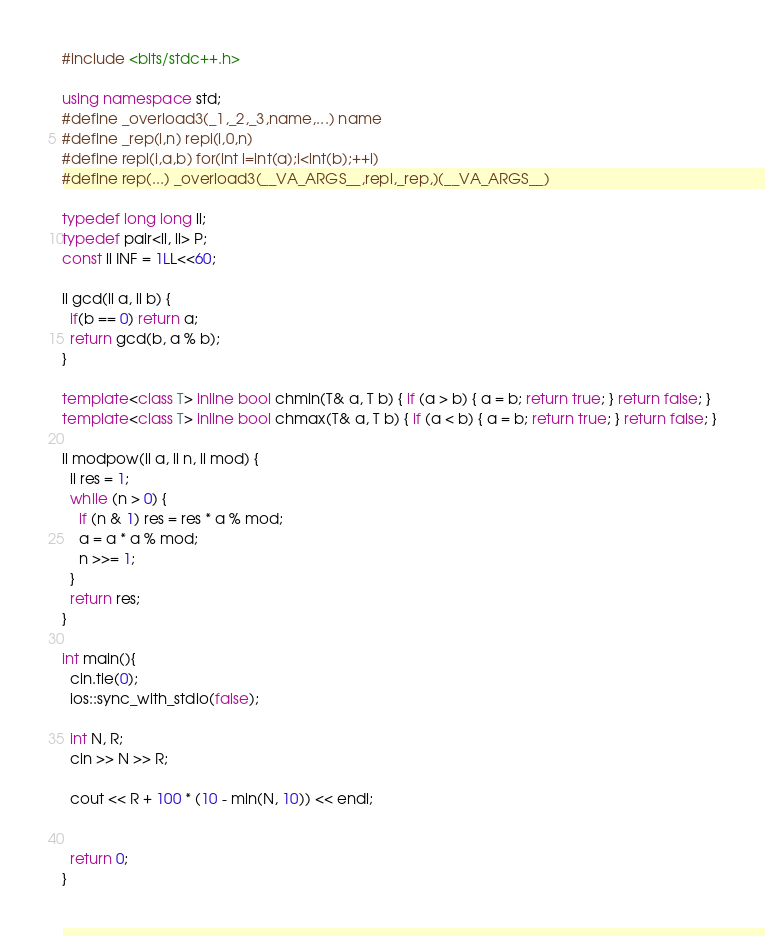Convert code to text. <code><loc_0><loc_0><loc_500><loc_500><_C++_>#include <bits/stdc++.h>

using namespace std;
#define _overload3(_1,_2,_3,name,...) name
#define _rep(i,n) repi(i,0,n)
#define repi(i,a,b) for(int i=int(a);i<int(b);++i)
#define rep(...) _overload3(__VA_ARGS__,repi,_rep,)(__VA_ARGS__)

typedef long long ll;
typedef pair<ll, ll> P;
const ll INF = 1LL<<60;

ll gcd(ll a, ll b) {
  if(b == 0) return a;
  return gcd(b, a % b);
}

template<class T> inline bool chmin(T& a, T b) { if (a > b) { a = b; return true; } return false; }
template<class T> inline bool chmax(T& a, T b) { if (a < b) { a = b; return true; } return false; }

ll modpow(ll a, ll n, ll mod) {
  ll res = 1;
  while (n > 0) {
    if (n & 1) res = res * a % mod;
    a = a * a % mod;
    n >>= 1;
  }
  return res;
}

int main(){
  cin.tie(0);
  ios::sync_with_stdio(false);

  int N, R;
  cin >> N >> R;

  cout << R + 100 * (10 - min(N, 10)) << endl;


  return 0;
}
</code> 